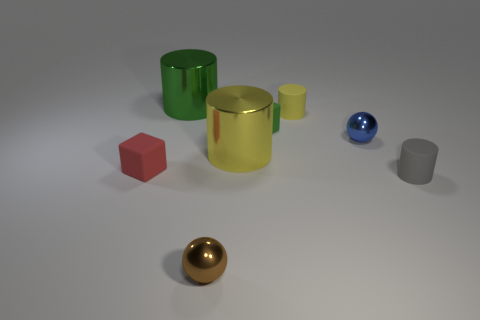Add 1 large purple shiny blocks. How many objects exist? 9 Subtract all cubes. How many objects are left? 6 Add 8 big red metal balls. How many big red metal balls exist? 8 Subtract 0 purple cubes. How many objects are left? 8 Subtract all cyan rubber spheres. Subtract all gray cylinders. How many objects are left? 7 Add 7 big green metallic things. How many big green metallic things are left? 8 